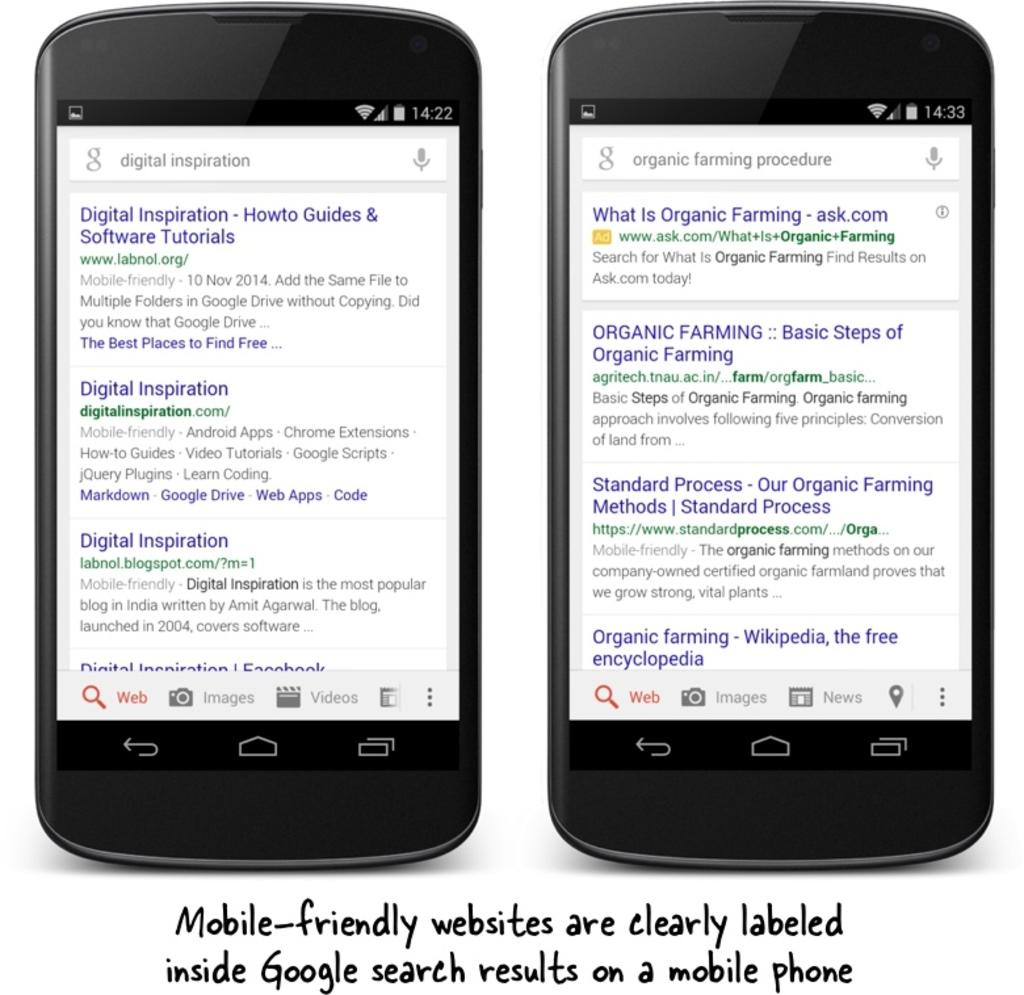<image>
Write a terse but informative summary of the picture. the words digital inspiration on the phone on the left 